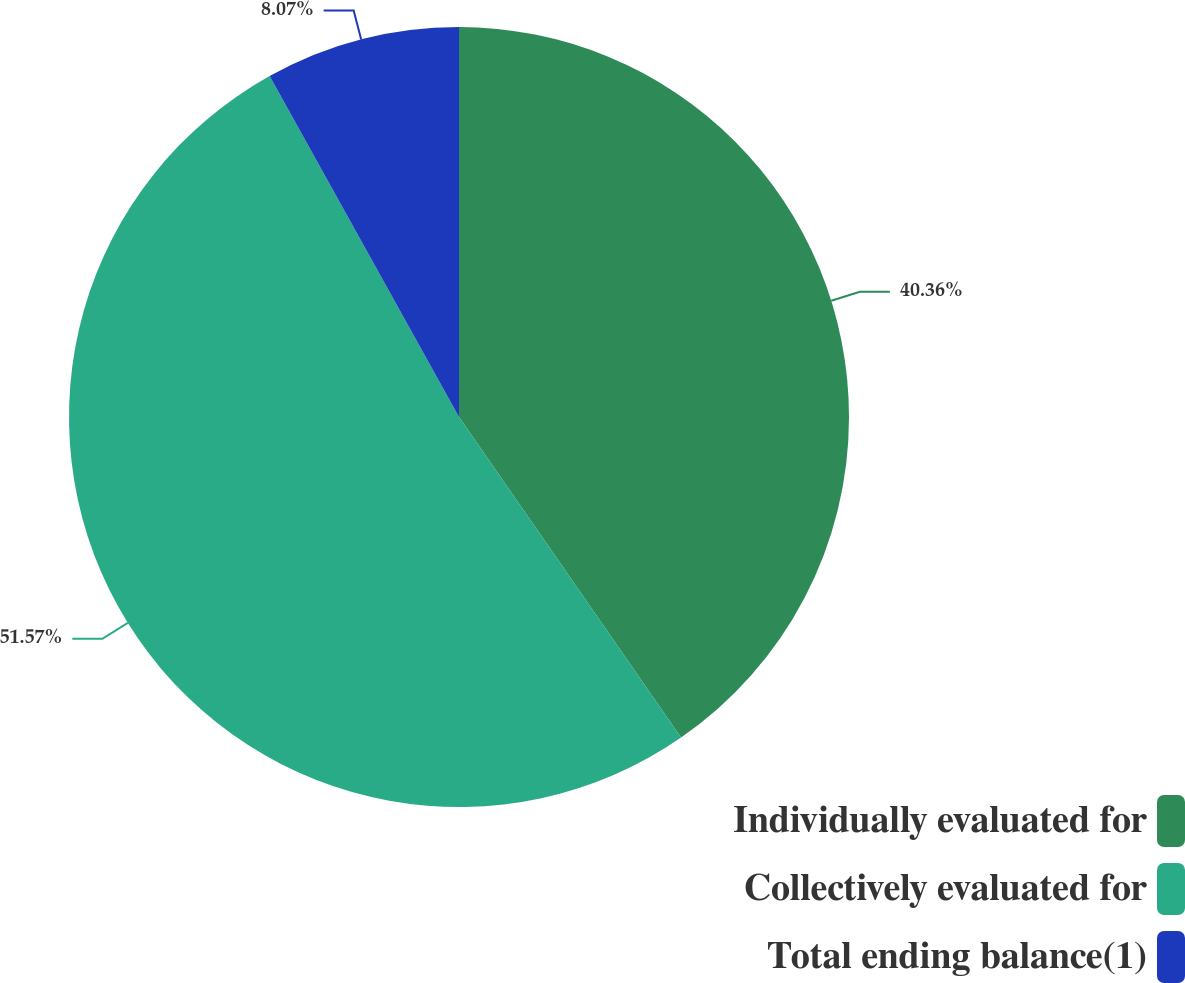Convert chart to OTSL. <chart><loc_0><loc_0><loc_500><loc_500><pie_chart><fcel>Individually evaluated for<fcel>Collectively evaluated for<fcel>Total ending balance(1)<nl><fcel>40.36%<fcel>51.57%<fcel>8.07%<nl></chart> 